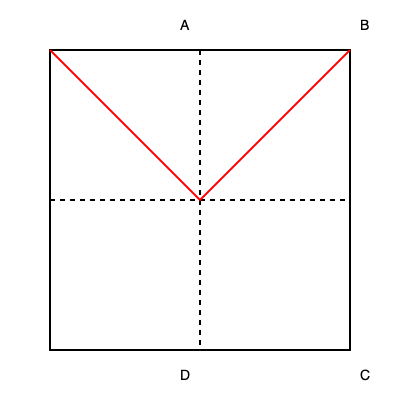Imagine folding a manuscript page to create an origami book shape. If you fold the top-right corner (B) to the center point, and then fold the top-left corner (A) to meet it, what shape will be formed by the creases? Let's approach this step-by-step:

1. The manuscript page is represented by the square ABCD.
2. The center point is where the dashed lines intersect.
3. When we fold corner B to the center:
   - It creates a diagonal crease from the top-right corner to the center.
4. When we fold corner A to meet B at the center:
   - It creates another diagonal crease from the top-left corner to the center.
5. These two creases together form a triangle:
   - The base of the triangle is the top edge of the page (AB).
   - The two sides are the creases created by folding corners A and B to the center.
6. In geometry, when two equal line segments meet at a point, they form an isosceles triangle.
7. Since both folds are from corners to the center, they are equal in length.

Therefore, the shape formed by the creases is an isosceles triangle, with its base being the top edge of the manuscript page and its apex at the center point.
Answer: Isosceles triangle 